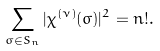<formula> <loc_0><loc_0><loc_500><loc_500>\sum _ { \sigma \in S _ { n } } | \chi ^ { ( \nu ) } ( \sigma ) | ^ { 2 } = n ! .</formula> 